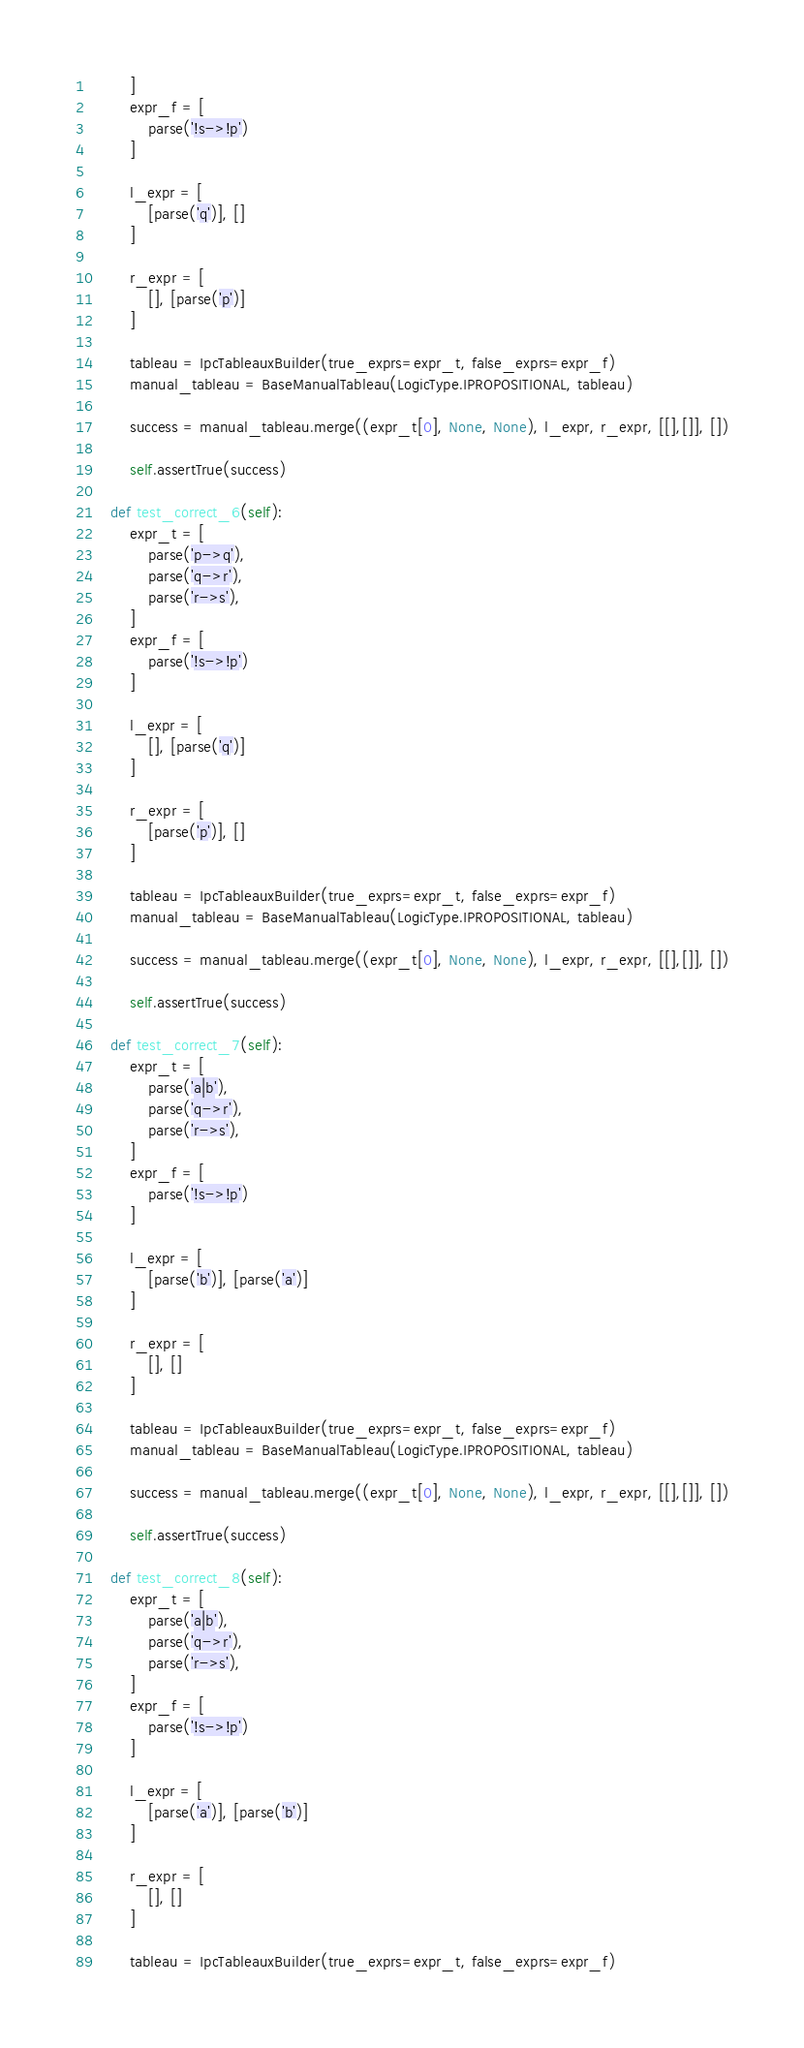<code> <loc_0><loc_0><loc_500><loc_500><_Python_>        ]
        expr_f = [
            parse('!s->!p')
        ]

        l_expr = [
            [parse('q')], []
        ]

        r_expr = [
            [], [parse('p')]
        ]

        tableau = IpcTableauxBuilder(true_exprs=expr_t, false_exprs=expr_f)
        manual_tableau = BaseManualTableau(LogicType.IPROPOSITIONAL, tableau)

        success = manual_tableau.merge((expr_t[0], None, None), l_expr, r_expr, [[],[]], [])

        self.assertTrue(success)
    
    def test_correct_6(self):
        expr_t = [
            parse('p->q'),
            parse('q->r'),
            parse('r->s'),
        ]
        expr_f = [
            parse('!s->!p')
        ]

        l_expr = [
            [], [parse('q')]
        ]

        r_expr = [
            [parse('p')], []
        ]

        tableau = IpcTableauxBuilder(true_exprs=expr_t, false_exprs=expr_f)
        manual_tableau = BaseManualTableau(LogicType.IPROPOSITIONAL, tableau)

        success = manual_tableau.merge((expr_t[0], None, None), l_expr, r_expr, [[],[]], [])

        self.assertTrue(success)
    
    def test_correct_7(self):
        expr_t = [
            parse('a|b'),
            parse('q->r'),
            parse('r->s'),
        ]
        expr_f = [
            parse('!s->!p')
        ]

        l_expr = [
            [parse('b')], [parse('a')]
        ]

        r_expr = [
            [], []
        ]

        tableau = IpcTableauxBuilder(true_exprs=expr_t, false_exprs=expr_f)
        manual_tableau = BaseManualTableau(LogicType.IPROPOSITIONAL, tableau)

        success = manual_tableau.merge((expr_t[0], None, None), l_expr, r_expr, [[],[]], [])

        self.assertTrue(success)
    
    def test_correct_8(self):
        expr_t = [
            parse('a|b'),
            parse('q->r'),
            parse('r->s'),
        ]
        expr_f = [
            parse('!s->!p')
        ]

        l_expr = [
            [parse('a')], [parse('b')]
        ]

        r_expr = [
            [], []
        ]

        tableau = IpcTableauxBuilder(true_exprs=expr_t, false_exprs=expr_f)</code> 